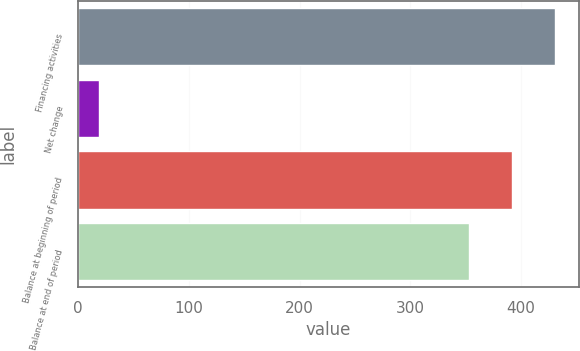Convert chart. <chart><loc_0><loc_0><loc_500><loc_500><bar_chart><fcel>Financing activities<fcel>Net change<fcel>Balance at beginning of period<fcel>Balance at end of period<nl><fcel>430.6<fcel>19<fcel>391.8<fcel>353<nl></chart> 